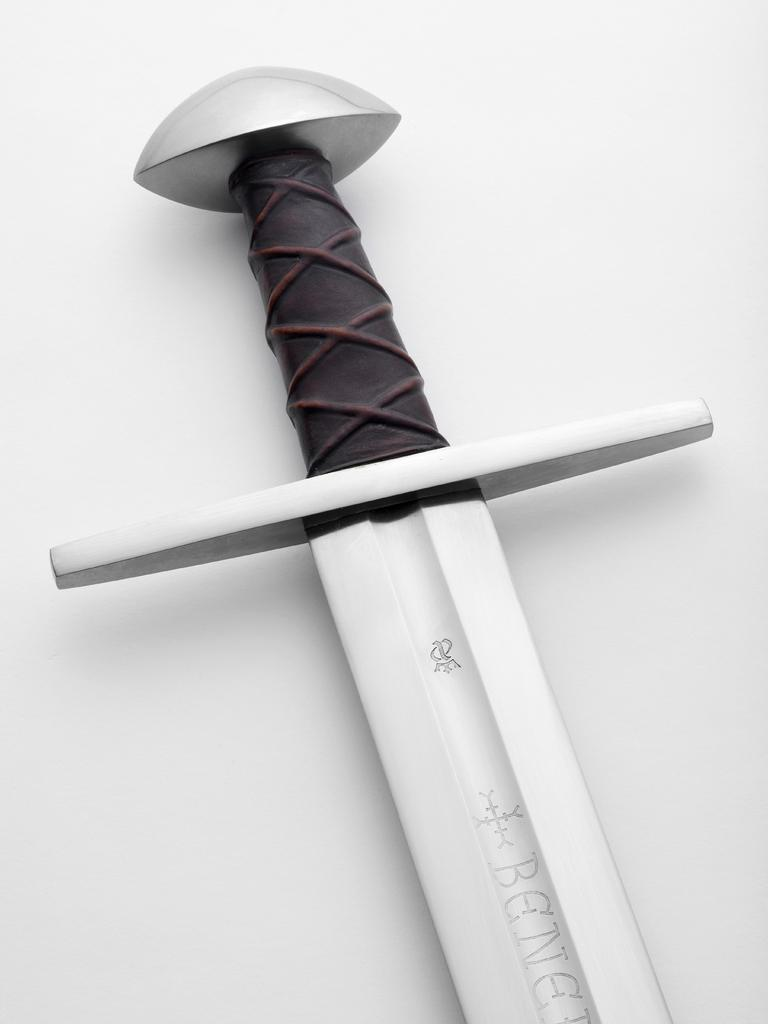What object is the main focus of the image? There is a sword in the image. What color is the background of the image? The background of the image is white. What type of toy can be seen playing volleyball in the image? There is no toy or volleyball present in the image; it features a sword and a white background. 